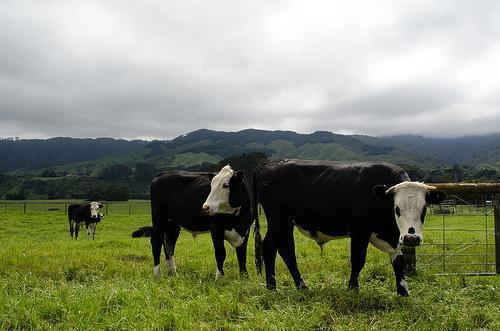How many cows are there?
Give a very brief answer. 4. How many cows are standing?
Give a very brief answer. 3. 